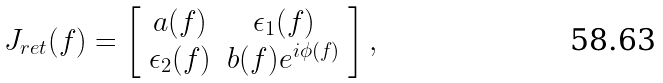<formula> <loc_0><loc_0><loc_500><loc_500>J _ { r e t } ( f ) = \left [ \begin{array} { c c } a ( f ) & \epsilon _ { 1 } ( f ) \\ \epsilon _ { 2 } ( f ) & b ( f ) e ^ { i \phi ( f ) } \end{array} \right ] ,</formula> 